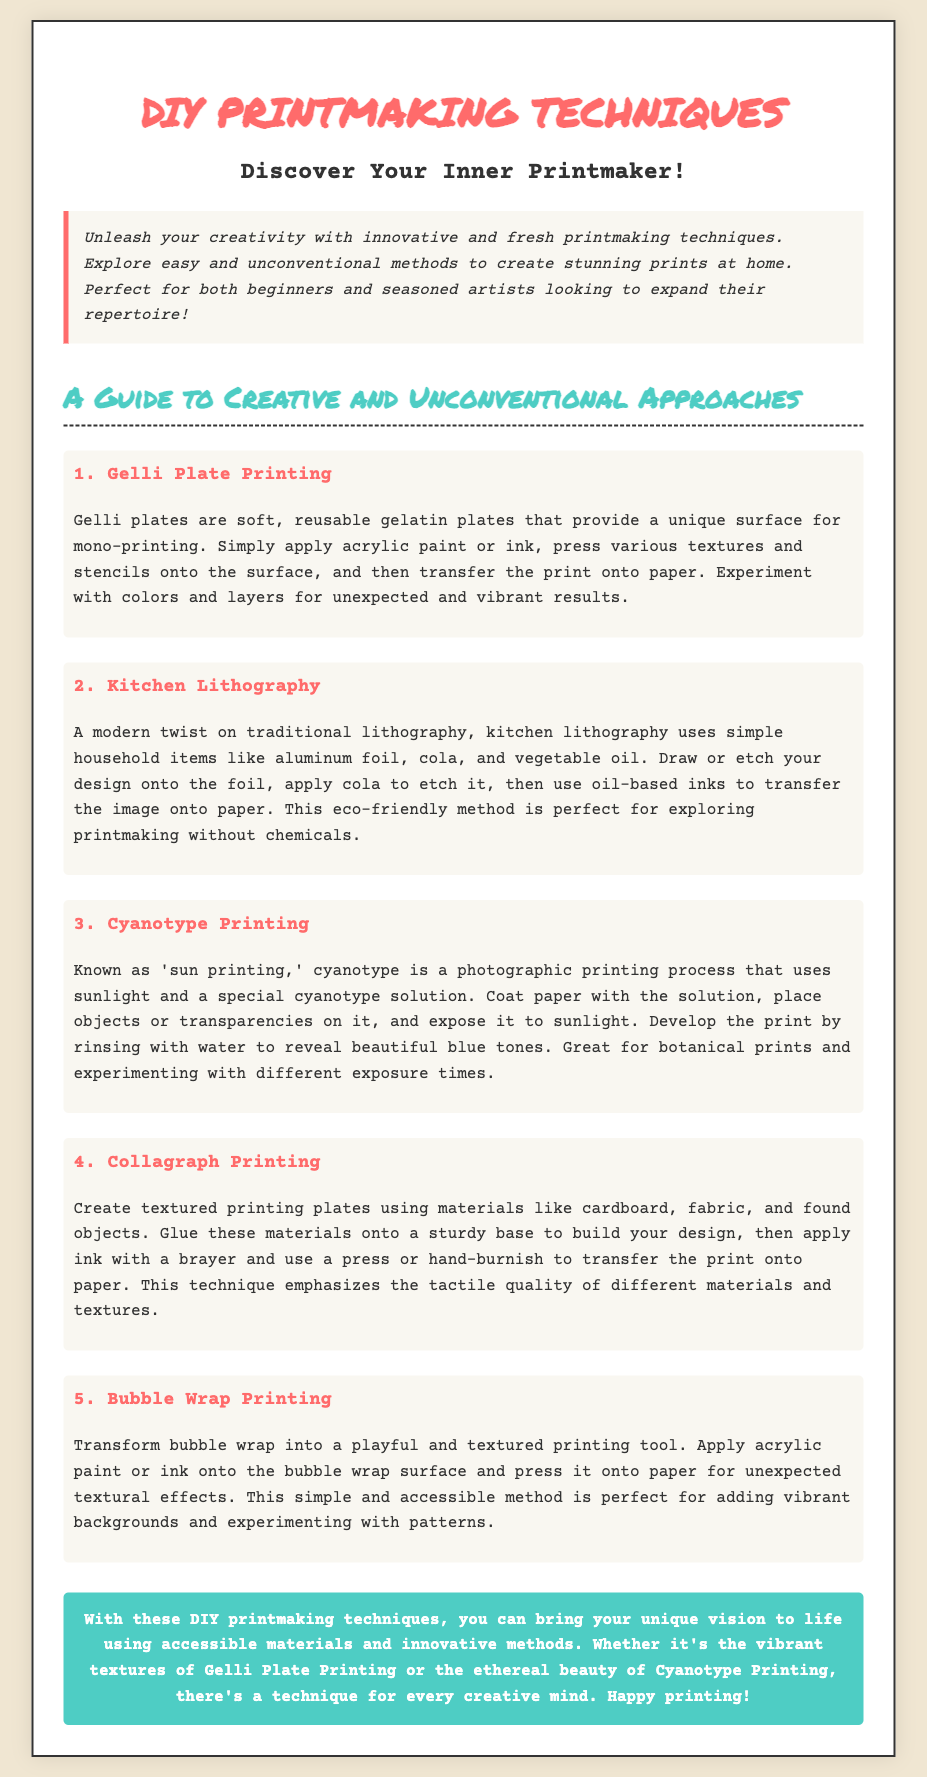What is the title of the flyer? The title appears prominently at the top of the flyer, indicating the main topic.
Answer: DIY Printmaking Techniques How many techniques are mentioned in the document? The document lists five different techniques for printmaking.
Answer: 5 What is the first technique described? The first technique is listed in the document, highlighting its unique approach.
Answer: Gelli Plate Printing Which printing technique uses sunlight? This question refers to a specific method detailed in the guide related to light exposure.
Answer: Cyanotype Printing What materials are used in Kitchen Lithography? The document specifies simple household items that are utilized in this unique printmaking method.
Answer: Aluminum foil, cola, vegetable oil What is the color of the conclusion's background? The background color of the conclusion section is noted in the styling of the document.
Answer: #4ecdc4 What type of printing is considered eco-friendly? This question targets a specific printmaking technique that emphasizes environmental considerations.
Answer: Kitchen Lithography What playful printing tool is mentioned? This refers to a specific material used in one of the techniques described in the document.
Answer: Bubble Wrap 